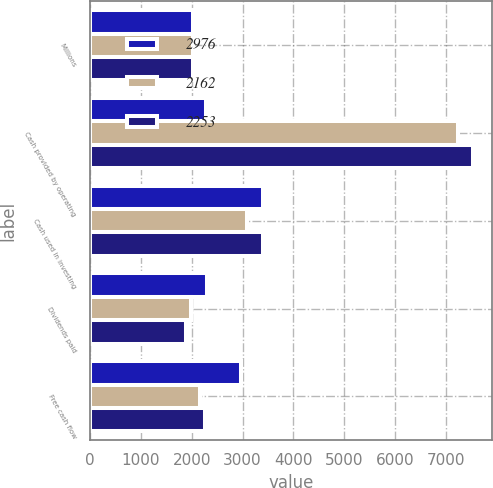Convert chart to OTSL. <chart><loc_0><loc_0><loc_500><loc_500><stacked_bar_chart><ecel><fcel>Millions<fcel>Cash provided by operating<fcel>Cash used in investing<fcel>Dividends paid<fcel>Free cash flow<nl><fcel>2976<fcel>2018<fcel>2276<fcel>3411<fcel>2299<fcel>2976<nl><fcel>2162<fcel>2017<fcel>7230<fcel>3086<fcel>1982<fcel>2162<nl><fcel>2253<fcel>2016<fcel>7525<fcel>3393<fcel>1879<fcel>2253<nl></chart> 